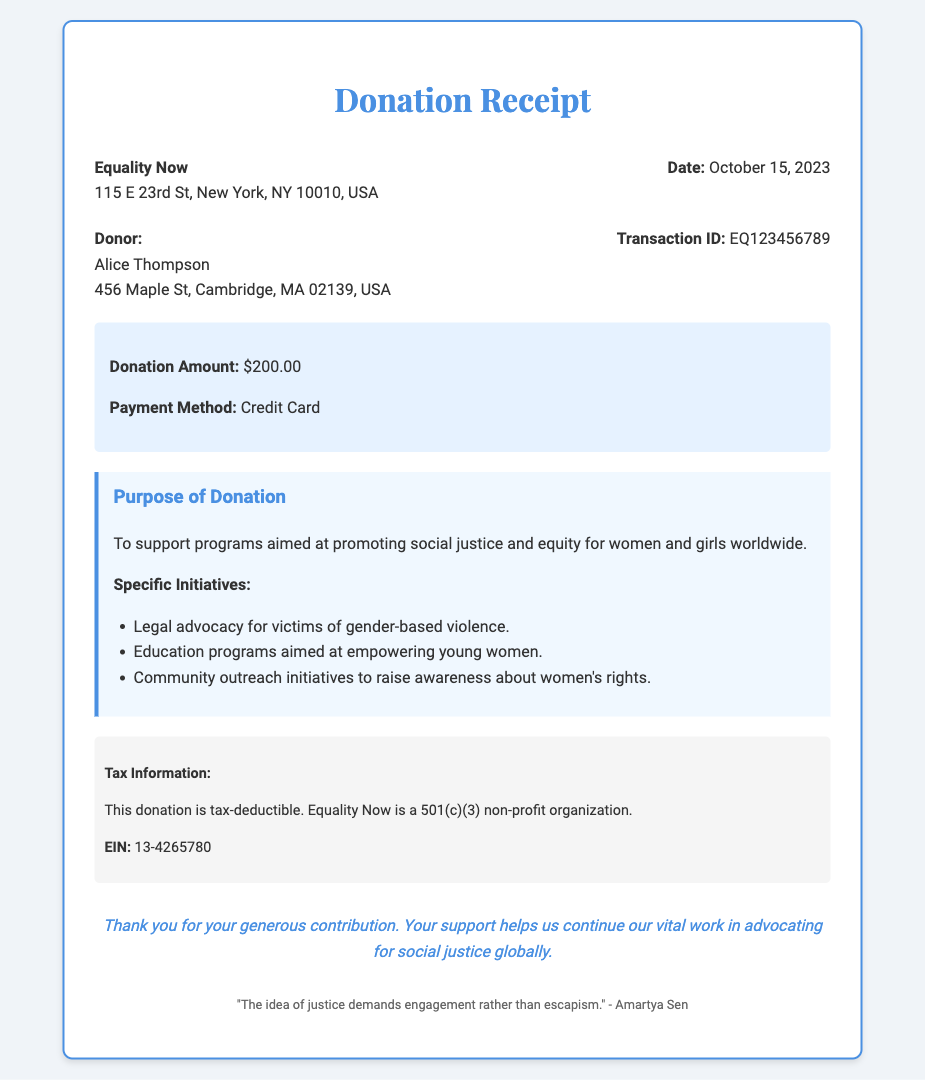What is the name of the organization? The organization name is specified in the header of the receipt.
Answer: Equality Now What is the donation amount? The donation amount is mentioned in the donation details section of the receipt.
Answer: $200.00 Who is the donor? The donor's name is indicated in the donor information section.
Answer: Alice Thompson What is the purpose of the donation? The purpose of the donation is described in the designated section.
Answer: To support programs aimed at promoting social justice and equity for women and girls worldwide What date was the donation received? The date is mentioned in the organization information section of the receipt.
Answer: October 15, 2023 What are some specific initiatives supported by the donation? The specific initiatives are listed under the purpose of donation section.
Answer: Legal advocacy for victims of gender-based violence, Education programs aimed at empowering young women, Community outreach initiatives to raise awareness about women's rights Is the donation tax-deductible? This is confirmed in the tax information section of the receipt.
Answer: Yes What is the transaction ID? The transaction ID is provided in the donor information section of the receipt.
Answer: EQ123456789 What is the EIN of the organization? The EIN is listed in the tax information section of the receipt.
Answer: 13-4265780 